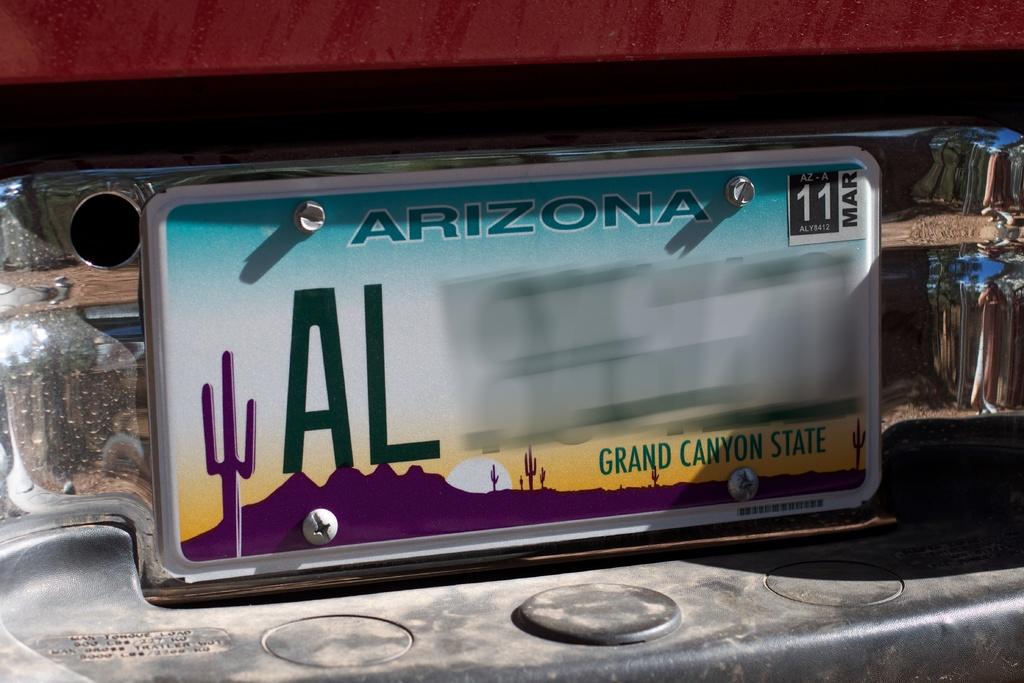What state is the tag from?
Offer a terse response. Arizona. What month is listed on the registration tag in the upper right corner?
Offer a terse response. March. 